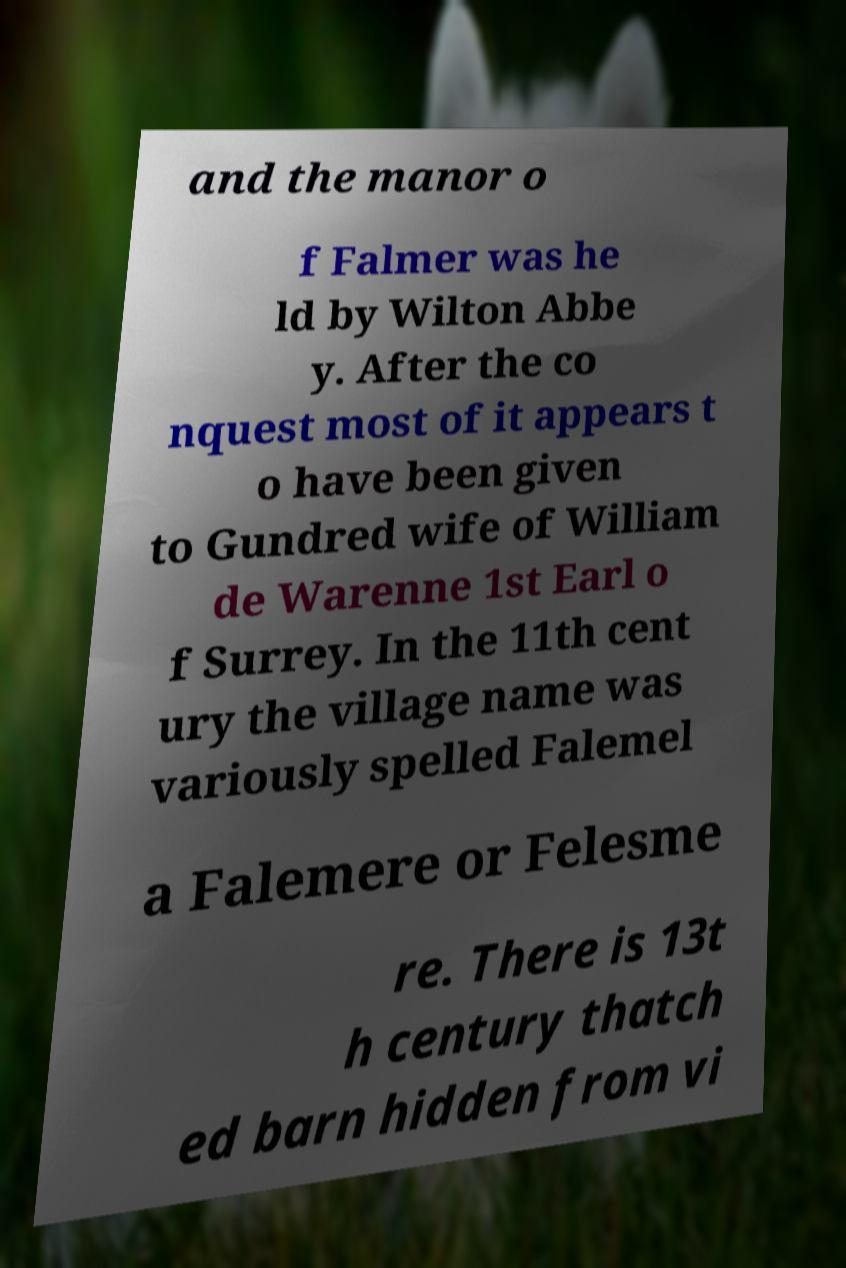Could you extract and type out the text from this image? and the manor o f Falmer was he ld by Wilton Abbe y. After the co nquest most of it appears t o have been given to Gundred wife of William de Warenne 1st Earl o f Surrey. In the 11th cent ury the village name was variously spelled Falemel a Falemere or Felesme re. There is 13t h century thatch ed barn hidden from vi 